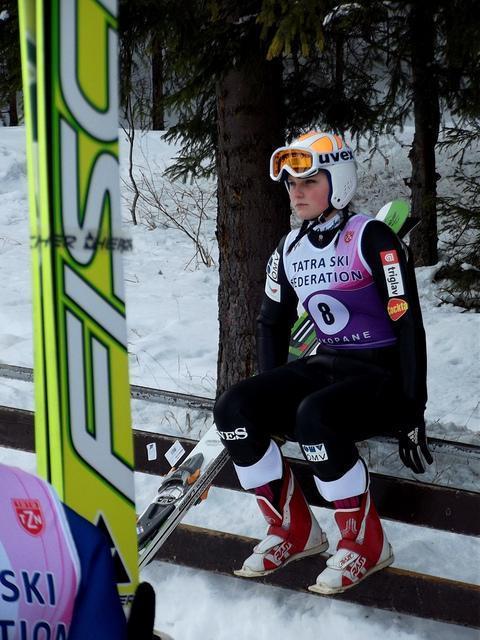How many ski are there?
Give a very brief answer. 2. How many people are there?
Give a very brief answer. 2. 